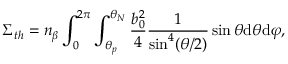Convert formula to latex. <formula><loc_0><loc_0><loc_500><loc_500>\Sigma _ { t h } = n _ { \beta } \int _ { 0 } ^ { 2 \pi } \int _ { \theta _ { p } } ^ { \theta _ { N } } \frac { b _ { 0 } ^ { 2 } } { 4 } \frac { 1 } { \sin ^ { 4 } ( \theta / 2 ) } \sin \theta d \theta d \varphi ,</formula> 